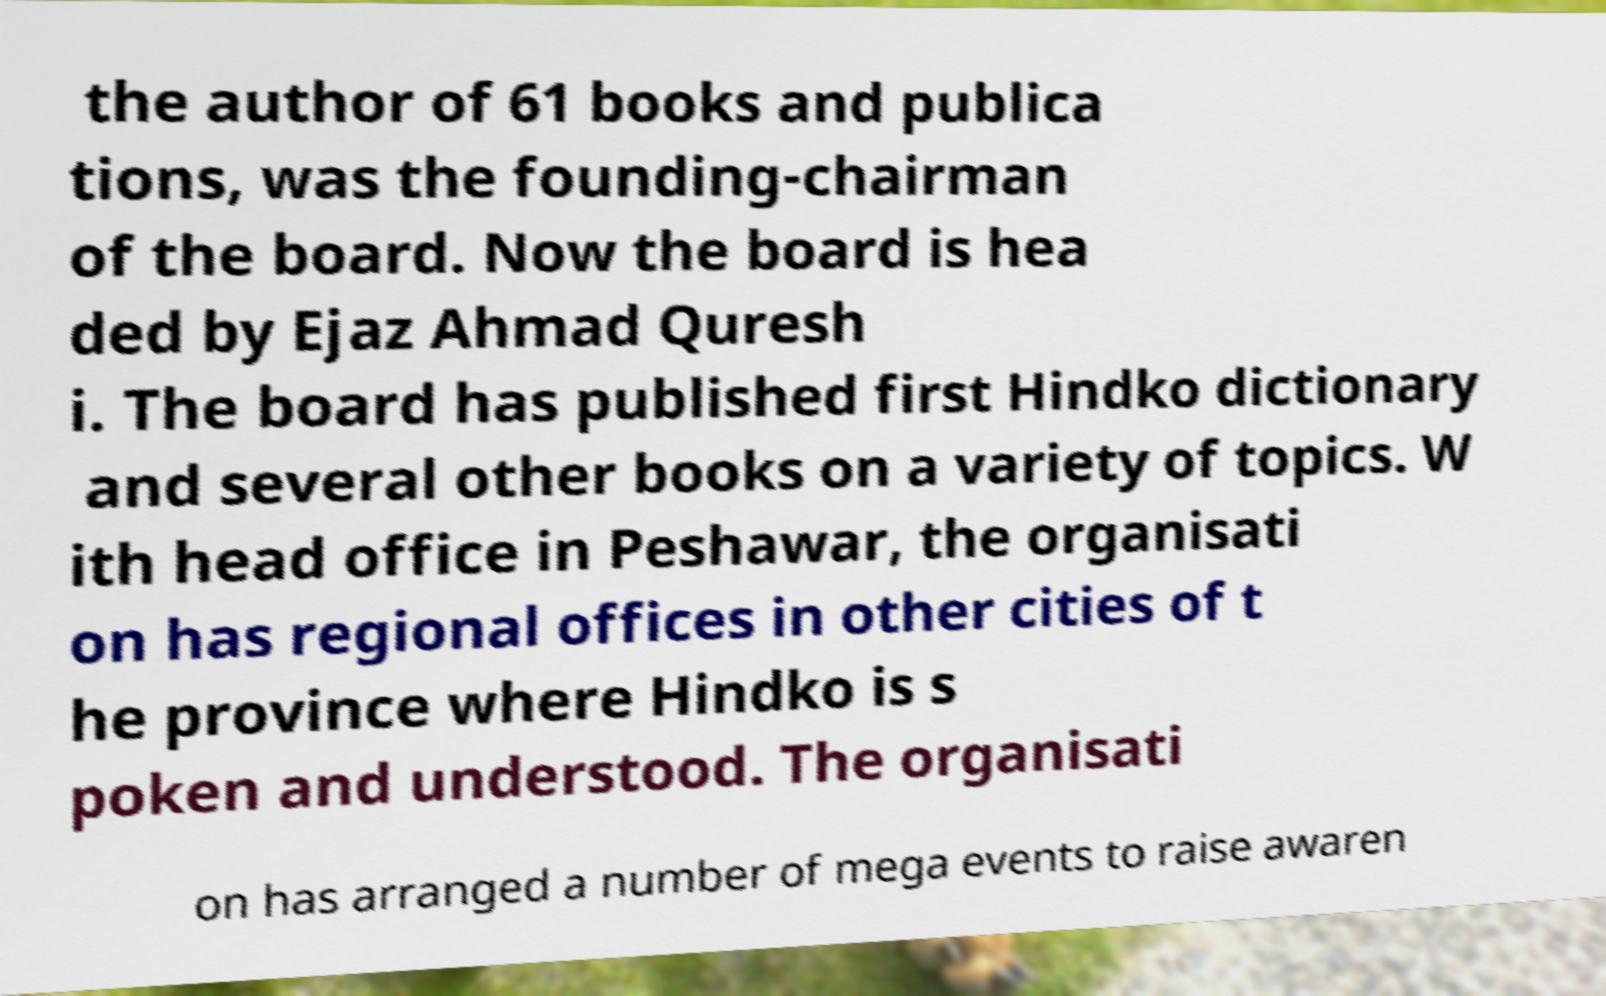Could you assist in decoding the text presented in this image and type it out clearly? the author of 61 books and publica tions, was the founding-chairman of the board. Now the board is hea ded by Ejaz Ahmad Quresh i. The board has published first Hindko dictionary and several other books on a variety of topics. W ith head office in Peshawar, the organisati on has regional offices in other cities of t he province where Hindko is s poken and understood. The organisati on has arranged a number of mega events to raise awaren 